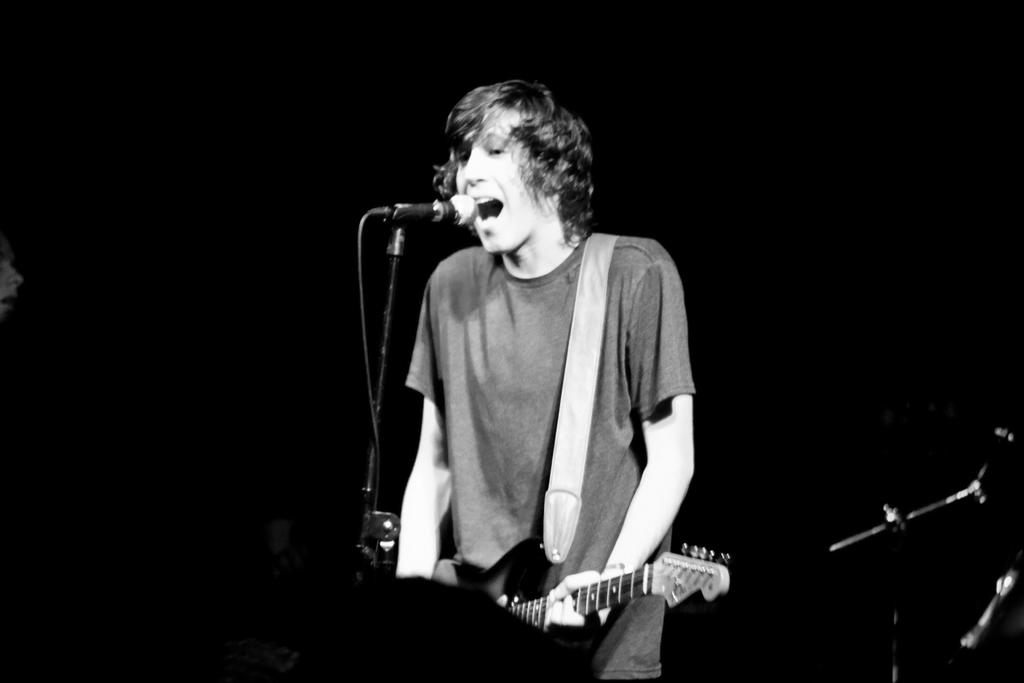What is the main subject of the image? There is a person in the image. What is the person doing in the image? The person is standing and singing. What object is the person standing in front of? The person is in front of a microphone. What instrument is the person holding? The person is holding a guitar. What type of dock can be seen in the background of the image? There is no dock present in the image; it features a person standing in front of a microphone and holding a guitar. 